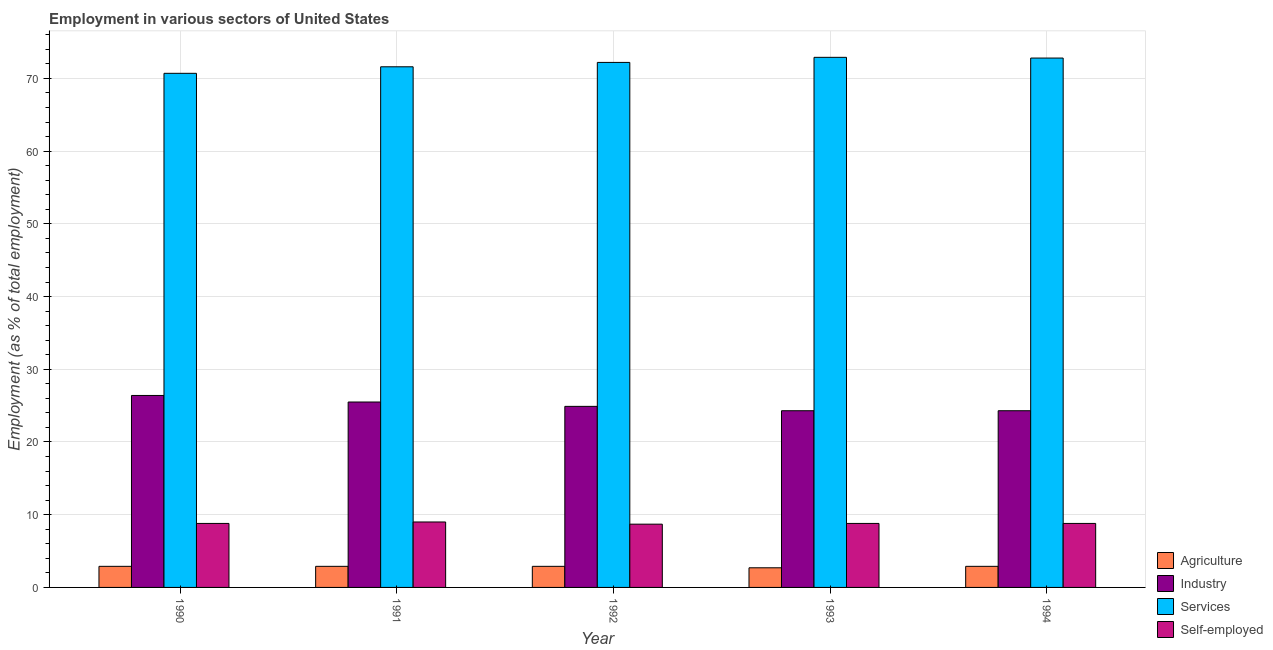How many different coloured bars are there?
Offer a terse response. 4. Are the number of bars per tick equal to the number of legend labels?
Offer a terse response. Yes. Are the number of bars on each tick of the X-axis equal?
Provide a short and direct response. Yes. How many bars are there on the 4th tick from the left?
Provide a succinct answer. 4. In how many cases, is the number of bars for a given year not equal to the number of legend labels?
Your answer should be very brief. 0. What is the percentage of workers in industry in 1990?
Your response must be concise. 26.4. Across all years, what is the maximum percentage of workers in industry?
Your answer should be compact. 26.4. Across all years, what is the minimum percentage of workers in agriculture?
Make the answer very short. 2.7. In which year was the percentage of workers in industry maximum?
Keep it short and to the point. 1990. What is the total percentage of workers in services in the graph?
Your answer should be compact. 360.2. What is the difference between the percentage of self employed workers in 1991 and that in 1994?
Keep it short and to the point. 0.2. What is the difference between the percentage of workers in services in 1991 and the percentage of workers in industry in 1994?
Provide a succinct answer. -1.2. What is the average percentage of workers in agriculture per year?
Your response must be concise. 2.86. In the year 1991, what is the difference between the percentage of workers in agriculture and percentage of workers in industry?
Provide a short and direct response. 0. In how many years, is the percentage of workers in services greater than 56 %?
Offer a terse response. 5. What is the ratio of the percentage of workers in services in 1991 to that in 1994?
Provide a succinct answer. 0.98. Is the percentage of workers in services in 1990 less than that in 1992?
Offer a very short reply. Yes. What is the difference between the highest and the second highest percentage of workers in agriculture?
Your answer should be compact. 0. What is the difference between the highest and the lowest percentage of workers in agriculture?
Keep it short and to the point. 0.2. Is it the case that in every year, the sum of the percentage of workers in services and percentage of self employed workers is greater than the sum of percentage of workers in agriculture and percentage of workers in industry?
Your answer should be very brief. Yes. What does the 2nd bar from the left in 1991 represents?
Provide a short and direct response. Industry. What does the 1st bar from the right in 1993 represents?
Your response must be concise. Self-employed. Are all the bars in the graph horizontal?
Provide a short and direct response. No. How many years are there in the graph?
Your response must be concise. 5. Does the graph contain grids?
Provide a succinct answer. Yes. How many legend labels are there?
Your answer should be very brief. 4. What is the title of the graph?
Give a very brief answer. Employment in various sectors of United States. Does "Quality of public administration" appear as one of the legend labels in the graph?
Your answer should be very brief. No. What is the label or title of the Y-axis?
Offer a very short reply. Employment (as % of total employment). What is the Employment (as % of total employment) in Agriculture in 1990?
Ensure brevity in your answer.  2.9. What is the Employment (as % of total employment) of Industry in 1990?
Offer a terse response. 26.4. What is the Employment (as % of total employment) in Services in 1990?
Your answer should be very brief. 70.7. What is the Employment (as % of total employment) of Self-employed in 1990?
Provide a short and direct response. 8.8. What is the Employment (as % of total employment) of Agriculture in 1991?
Make the answer very short. 2.9. What is the Employment (as % of total employment) of Industry in 1991?
Offer a very short reply. 25.5. What is the Employment (as % of total employment) of Services in 1991?
Provide a short and direct response. 71.6. What is the Employment (as % of total employment) of Agriculture in 1992?
Your answer should be compact. 2.9. What is the Employment (as % of total employment) of Industry in 1992?
Make the answer very short. 24.9. What is the Employment (as % of total employment) in Services in 1992?
Give a very brief answer. 72.2. What is the Employment (as % of total employment) in Self-employed in 1992?
Offer a very short reply. 8.7. What is the Employment (as % of total employment) of Agriculture in 1993?
Offer a terse response. 2.7. What is the Employment (as % of total employment) of Industry in 1993?
Offer a very short reply. 24.3. What is the Employment (as % of total employment) in Services in 1993?
Your answer should be very brief. 72.9. What is the Employment (as % of total employment) in Self-employed in 1993?
Keep it short and to the point. 8.8. What is the Employment (as % of total employment) in Agriculture in 1994?
Offer a very short reply. 2.9. What is the Employment (as % of total employment) of Industry in 1994?
Keep it short and to the point. 24.3. What is the Employment (as % of total employment) in Services in 1994?
Your answer should be very brief. 72.8. What is the Employment (as % of total employment) in Self-employed in 1994?
Your answer should be compact. 8.8. Across all years, what is the maximum Employment (as % of total employment) of Agriculture?
Keep it short and to the point. 2.9. Across all years, what is the maximum Employment (as % of total employment) of Industry?
Your answer should be compact. 26.4. Across all years, what is the maximum Employment (as % of total employment) of Services?
Offer a terse response. 72.9. Across all years, what is the maximum Employment (as % of total employment) of Self-employed?
Offer a terse response. 9. Across all years, what is the minimum Employment (as % of total employment) in Agriculture?
Provide a short and direct response. 2.7. Across all years, what is the minimum Employment (as % of total employment) of Industry?
Offer a very short reply. 24.3. Across all years, what is the minimum Employment (as % of total employment) of Services?
Make the answer very short. 70.7. Across all years, what is the minimum Employment (as % of total employment) of Self-employed?
Your answer should be very brief. 8.7. What is the total Employment (as % of total employment) of Agriculture in the graph?
Your answer should be very brief. 14.3. What is the total Employment (as % of total employment) in Industry in the graph?
Provide a short and direct response. 125.4. What is the total Employment (as % of total employment) in Services in the graph?
Provide a succinct answer. 360.2. What is the total Employment (as % of total employment) of Self-employed in the graph?
Provide a succinct answer. 44.1. What is the difference between the Employment (as % of total employment) of Agriculture in 1990 and that in 1991?
Your answer should be very brief. 0. What is the difference between the Employment (as % of total employment) of Industry in 1990 and that in 1991?
Ensure brevity in your answer.  0.9. What is the difference between the Employment (as % of total employment) in Agriculture in 1990 and that in 1992?
Offer a very short reply. 0. What is the difference between the Employment (as % of total employment) of Services in 1990 and that in 1992?
Your response must be concise. -1.5. What is the difference between the Employment (as % of total employment) in Self-employed in 1990 and that in 1992?
Provide a succinct answer. 0.1. What is the difference between the Employment (as % of total employment) of Agriculture in 1990 and that in 1993?
Your answer should be very brief. 0.2. What is the difference between the Employment (as % of total employment) of Self-employed in 1990 and that in 1993?
Give a very brief answer. 0. What is the difference between the Employment (as % of total employment) of Industry in 1990 and that in 1994?
Offer a terse response. 2.1. What is the difference between the Employment (as % of total employment) of Self-employed in 1990 and that in 1994?
Your answer should be very brief. 0. What is the difference between the Employment (as % of total employment) of Services in 1991 and that in 1992?
Keep it short and to the point. -0.6. What is the difference between the Employment (as % of total employment) of Self-employed in 1991 and that in 1992?
Provide a succinct answer. 0.3. What is the difference between the Employment (as % of total employment) of Services in 1991 and that in 1993?
Provide a succinct answer. -1.3. What is the difference between the Employment (as % of total employment) in Self-employed in 1991 and that in 1993?
Give a very brief answer. 0.2. What is the difference between the Employment (as % of total employment) of Services in 1991 and that in 1994?
Offer a very short reply. -1.2. What is the difference between the Employment (as % of total employment) of Industry in 1992 and that in 1993?
Offer a terse response. 0.6. What is the difference between the Employment (as % of total employment) in Services in 1992 and that in 1993?
Offer a terse response. -0.7. What is the difference between the Employment (as % of total employment) of Industry in 1992 and that in 1994?
Give a very brief answer. 0.6. What is the difference between the Employment (as % of total employment) in Agriculture in 1993 and that in 1994?
Offer a terse response. -0.2. What is the difference between the Employment (as % of total employment) in Services in 1993 and that in 1994?
Make the answer very short. 0.1. What is the difference between the Employment (as % of total employment) of Agriculture in 1990 and the Employment (as % of total employment) of Industry in 1991?
Offer a very short reply. -22.6. What is the difference between the Employment (as % of total employment) in Agriculture in 1990 and the Employment (as % of total employment) in Services in 1991?
Your answer should be compact. -68.7. What is the difference between the Employment (as % of total employment) of Agriculture in 1990 and the Employment (as % of total employment) of Self-employed in 1991?
Offer a terse response. -6.1. What is the difference between the Employment (as % of total employment) in Industry in 1990 and the Employment (as % of total employment) in Services in 1991?
Offer a terse response. -45.2. What is the difference between the Employment (as % of total employment) in Industry in 1990 and the Employment (as % of total employment) in Self-employed in 1991?
Make the answer very short. 17.4. What is the difference between the Employment (as % of total employment) of Services in 1990 and the Employment (as % of total employment) of Self-employed in 1991?
Keep it short and to the point. 61.7. What is the difference between the Employment (as % of total employment) in Agriculture in 1990 and the Employment (as % of total employment) in Industry in 1992?
Provide a short and direct response. -22. What is the difference between the Employment (as % of total employment) in Agriculture in 1990 and the Employment (as % of total employment) in Services in 1992?
Your response must be concise. -69.3. What is the difference between the Employment (as % of total employment) in Agriculture in 1990 and the Employment (as % of total employment) in Self-employed in 1992?
Make the answer very short. -5.8. What is the difference between the Employment (as % of total employment) of Industry in 1990 and the Employment (as % of total employment) of Services in 1992?
Your answer should be very brief. -45.8. What is the difference between the Employment (as % of total employment) in Industry in 1990 and the Employment (as % of total employment) in Self-employed in 1992?
Your answer should be very brief. 17.7. What is the difference between the Employment (as % of total employment) of Agriculture in 1990 and the Employment (as % of total employment) of Industry in 1993?
Make the answer very short. -21.4. What is the difference between the Employment (as % of total employment) in Agriculture in 1990 and the Employment (as % of total employment) in Services in 1993?
Give a very brief answer. -70. What is the difference between the Employment (as % of total employment) of Industry in 1990 and the Employment (as % of total employment) of Services in 1993?
Your answer should be compact. -46.5. What is the difference between the Employment (as % of total employment) of Industry in 1990 and the Employment (as % of total employment) of Self-employed in 1993?
Your answer should be compact. 17.6. What is the difference between the Employment (as % of total employment) of Services in 1990 and the Employment (as % of total employment) of Self-employed in 1993?
Provide a short and direct response. 61.9. What is the difference between the Employment (as % of total employment) of Agriculture in 1990 and the Employment (as % of total employment) of Industry in 1994?
Make the answer very short. -21.4. What is the difference between the Employment (as % of total employment) in Agriculture in 1990 and the Employment (as % of total employment) in Services in 1994?
Your answer should be compact. -69.9. What is the difference between the Employment (as % of total employment) in Industry in 1990 and the Employment (as % of total employment) in Services in 1994?
Offer a terse response. -46.4. What is the difference between the Employment (as % of total employment) in Industry in 1990 and the Employment (as % of total employment) in Self-employed in 1994?
Make the answer very short. 17.6. What is the difference between the Employment (as % of total employment) in Services in 1990 and the Employment (as % of total employment) in Self-employed in 1994?
Make the answer very short. 61.9. What is the difference between the Employment (as % of total employment) of Agriculture in 1991 and the Employment (as % of total employment) of Industry in 1992?
Keep it short and to the point. -22. What is the difference between the Employment (as % of total employment) of Agriculture in 1991 and the Employment (as % of total employment) of Services in 1992?
Provide a short and direct response. -69.3. What is the difference between the Employment (as % of total employment) in Industry in 1991 and the Employment (as % of total employment) in Services in 1992?
Ensure brevity in your answer.  -46.7. What is the difference between the Employment (as % of total employment) in Industry in 1991 and the Employment (as % of total employment) in Self-employed in 1992?
Offer a very short reply. 16.8. What is the difference between the Employment (as % of total employment) in Services in 1991 and the Employment (as % of total employment) in Self-employed in 1992?
Your response must be concise. 62.9. What is the difference between the Employment (as % of total employment) in Agriculture in 1991 and the Employment (as % of total employment) in Industry in 1993?
Ensure brevity in your answer.  -21.4. What is the difference between the Employment (as % of total employment) of Agriculture in 1991 and the Employment (as % of total employment) of Services in 1993?
Give a very brief answer. -70. What is the difference between the Employment (as % of total employment) of Industry in 1991 and the Employment (as % of total employment) of Services in 1993?
Keep it short and to the point. -47.4. What is the difference between the Employment (as % of total employment) in Services in 1991 and the Employment (as % of total employment) in Self-employed in 1993?
Make the answer very short. 62.8. What is the difference between the Employment (as % of total employment) of Agriculture in 1991 and the Employment (as % of total employment) of Industry in 1994?
Offer a terse response. -21.4. What is the difference between the Employment (as % of total employment) of Agriculture in 1991 and the Employment (as % of total employment) of Services in 1994?
Your response must be concise. -69.9. What is the difference between the Employment (as % of total employment) of Industry in 1991 and the Employment (as % of total employment) of Services in 1994?
Provide a short and direct response. -47.3. What is the difference between the Employment (as % of total employment) in Services in 1991 and the Employment (as % of total employment) in Self-employed in 1994?
Make the answer very short. 62.8. What is the difference between the Employment (as % of total employment) of Agriculture in 1992 and the Employment (as % of total employment) of Industry in 1993?
Ensure brevity in your answer.  -21.4. What is the difference between the Employment (as % of total employment) in Agriculture in 1992 and the Employment (as % of total employment) in Services in 1993?
Provide a succinct answer. -70. What is the difference between the Employment (as % of total employment) in Industry in 1992 and the Employment (as % of total employment) in Services in 1993?
Your response must be concise. -48. What is the difference between the Employment (as % of total employment) of Industry in 1992 and the Employment (as % of total employment) of Self-employed in 1993?
Offer a very short reply. 16.1. What is the difference between the Employment (as % of total employment) in Services in 1992 and the Employment (as % of total employment) in Self-employed in 1993?
Make the answer very short. 63.4. What is the difference between the Employment (as % of total employment) of Agriculture in 1992 and the Employment (as % of total employment) of Industry in 1994?
Keep it short and to the point. -21.4. What is the difference between the Employment (as % of total employment) of Agriculture in 1992 and the Employment (as % of total employment) of Services in 1994?
Offer a very short reply. -69.9. What is the difference between the Employment (as % of total employment) in Agriculture in 1992 and the Employment (as % of total employment) in Self-employed in 1994?
Give a very brief answer. -5.9. What is the difference between the Employment (as % of total employment) of Industry in 1992 and the Employment (as % of total employment) of Services in 1994?
Provide a succinct answer. -47.9. What is the difference between the Employment (as % of total employment) in Services in 1992 and the Employment (as % of total employment) in Self-employed in 1994?
Provide a short and direct response. 63.4. What is the difference between the Employment (as % of total employment) in Agriculture in 1993 and the Employment (as % of total employment) in Industry in 1994?
Provide a succinct answer. -21.6. What is the difference between the Employment (as % of total employment) in Agriculture in 1993 and the Employment (as % of total employment) in Services in 1994?
Offer a very short reply. -70.1. What is the difference between the Employment (as % of total employment) of Agriculture in 1993 and the Employment (as % of total employment) of Self-employed in 1994?
Your response must be concise. -6.1. What is the difference between the Employment (as % of total employment) in Industry in 1993 and the Employment (as % of total employment) in Services in 1994?
Give a very brief answer. -48.5. What is the difference between the Employment (as % of total employment) in Services in 1993 and the Employment (as % of total employment) in Self-employed in 1994?
Provide a short and direct response. 64.1. What is the average Employment (as % of total employment) in Agriculture per year?
Your response must be concise. 2.86. What is the average Employment (as % of total employment) in Industry per year?
Your answer should be very brief. 25.08. What is the average Employment (as % of total employment) of Services per year?
Provide a short and direct response. 72.04. What is the average Employment (as % of total employment) in Self-employed per year?
Your answer should be compact. 8.82. In the year 1990, what is the difference between the Employment (as % of total employment) in Agriculture and Employment (as % of total employment) in Industry?
Ensure brevity in your answer.  -23.5. In the year 1990, what is the difference between the Employment (as % of total employment) of Agriculture and Employment (as % of total employment) of Services?
Your answer should be compact. -67.8. In the year 1990, what is the difference between the Employment (as % of total employment) of Agriculture and Employment (as % of total employment) of Self-employed?
Offer a terse response. -5.9. In the year 1990, what is the difference between the Employment (as % of total employment) in Industry and Employment (as % of total employment) in Services?
Offer a very short reply. -44.3. In the year 1990, what is the difference between the Employment (as % of total employment) of Industry and Employment (as % of total employment) of Self-employed?
Make the answer very short. 17.6. In the year 1990, what is the difference between the Employment (as % of total employment) of Services and Employment (as % of total employment) of Self-employed?
Offer a very short reply. 61.9. In the year 1991, what is the difference between the Employment (as % of total employment) of Agriculture and Employment (as % of total employment) of Industry?
Give a very brief answer. -22.6. In the year 1991, what is the difference between the Employment (as % of total employment) in Agriculture and Employment (as % of total employment) in Services?
Provide a succinct answer. -68.7. In the year 1991, what is the difference between the Employment (as % of total employment) of Industry and Employment (as % of total employment) of Services?
Ensure brevity in your answer.  -46.1. In the year 1991, what is the difference between the Employment (as % of total employment) of Services and Employment (as % of total employment) of Self-employed?
Give a very brief answer. 62.6. In the year 1992, what is the difference between the Employment (as % of total employment) in Agriculture and Employment (as % of total employment) in Services?
Your answer should be very brief. -69.3. In the year 1992, what is the difference between the Employment (as % of total employment) of Agriculture and Employment (as % of total employment) of Self-employed?
Your response must be concise. -5.8. In the year 1992, what is the difference between the Employment (as % of total employment) of Industry and Employment (as % of total employment) of Services?
Provide a short and direct response. -47.3. In the year 1992, what is the difference between the Employment (as % of total employment) of Services and Employment (as % of total employment) of Self-employed?
Give a very brief answer. 63.5. In the year 1993, what is the difference between the Employment (as % of total employment) of Agriculture and Employment (as % of total employment) of Industry?
Offer a terse response. -21.6. In the year 1993, what is the difference between the Employment (as % of total employment) of Agriculture and Employment (as % of total employment) of Services?
Make the answer very short. -70.2. In the year 1993, what is the difference between the Employment (as % of total employment) of Agriculture and Employment (as % of total employment) of Self-employed?
Give a very brief answer. -6.1. In the year 1993, what is the difference between the Employment (as % of total employment) of Industry and Employment (as % of total employment) of Services?
Offer a terse response. -48.6. In the year 1993, what is the difference between the Employment (as % of total employment) in Industry and Employment (as % of total employment) in Self-employed?
Ensure brevity in your answer.  15.5. In the year 1993, what is the difference between the Employment (as % of total employment) in Services and Employment (as % of total employment) in Self-employed?
Keep it short and to the point. 64.1. In the year 1994, what is the difference between the Employment (as % of total employment) in Agriculture and Employment (as % of total employment) in Industry?
Make the answer very short. -21.4. In the year 1994, what is the difference between the Employment (as % of total employment) in Agriculture and Employment (as % of total employment) in Services?
Provide a short and direct response. -69.9. In the year 1994, what is the difference between the Employment (as % of total employment) in Industry and Employment (as % of total employment) in Services?
Offer a very short reply. -48.5. In the year 1994, what is the difference between the Employment (as % of total employment) of Industry and Employment (as % of total employment) of Self-employed?
Give a very brief answer. 15.5. What is the ratio of the Employment (as % of total employment) of Industry in 1990 to that in 1991?
Provide a short and direct response. 1.04. What is the ratio of the Employment (as % of total employment) in Services in 1990 to that in 1991?
Make the answer very short. 0.99. What is the ratio of the Employment (as % of total employment) in Self-employed in 1990 to that in 1991?
Give a very brief answer. 0.98. What is the ratio of the Employment (as % of total employment) of Agriculture in 1990 to that in 1992?
Provide a succinct answer. 1. What is the ratio of the Employment (as % of total employment) in Industry in 1990 to that in 1992?
Provide a succinct answer. 1.06. What is the ratio of the Employment (as % of total employment) in Services in 1990 to that in 1992?
Give a very brief answer. 0.98. What is the ratio of the Employment (as % of total employment) in Self-employed in 1990 to that in 1992?
Keep it short and to the point. 1.01. What is the ratio of the Employment (as % of total employment) of Agriculture in 1990 to that in 1993?
Provide a succinct answer. 1.07. What is the ratio of the Employment (as % of total employment) of Industry in 1990 to that in 1993?
Provide a short and direct response. 1.09. What is the ratio of the Employment (as % of total employment) in Services in 1990 to that in 1993?
Keep it short and to the point. 0.97. What is the ratio of the Employment (as % of total employment) of Self-employed in 1990 to that in 1993?
Offer a very short reply. 1. What is the ratio of the Employment (as % of total employment) of Industry in 1990 to that in 1994?
Offer a terse response. 1.09. What is the ratio of the Employment (as % of total employment) of Services in 1990 to that in 1994?
Provide a short and direct response. 0.97. What is the ratio of the Employment (as % of total employment) in Agriculture in 1991 to that in 1992?
Make the answer very short. 1. What is the ratio of the Employment (as % of total employment) of Industry in 1991 to that in 1992?
Your response must be concise. 1.02. What is the ratio of the Employment (as % of total employment) of Services in 1991 to that in 1992?
Offer a terse response. 0.99. What is the ratio of the Employment (as % of total employment) in Self-employed in 1991 to that in 1992?
Provide a succinct answer. 1.03. What is the ratio of the Employment (as % of total employment) in Agriculture in 1991 to that in 1993?
Give a very brief answer. 1.07. What is the ratio of the Employment (as % of total employment) in Industry in 1991 to that in 1993?
Give a very brief answer. 1.05. What is the ratio of the Employment (as % of total employment) in Services in 1991 to that in 1993?
Your response must be concise. 0.98. What is the ratio of the Employment (as % of total employment) in Self-employed in 1991 to that in 1993?
Make the answer very short. 1.02. What is the ratio of the Employment (as % of total employment) of Agriculture in 1991 to that in 1994?
Give a very brief answer. 1. What is the ratio of the Employment (as % of total employment) in Industry in 1991 to that in 1994?
Provide a succinct answer. 1.05. What is the ratio of the Employment (as % of total employment) in Services in 1991 to that in 1994?
Make the answer very short. 0.98. What is the ratio of the Employment (as % of total employment) of Self-employed in 1991 to that in 1994?
Keep it short and to the point. 1.02. What is the ratio of the Employment (as % of total employment) of Agriculture in 1992 to that in 1993?
Keep it short and to the point. 1.07. What is the ratio of the Employment (as % of total employment) of Industry in 1992 to that in 1993?
Provide a succinct answer. 1.02. What is the ratio of the Employment (as % of total employment) of Services in 1992 to that in 1993?
Keep it short and to the point. 0.99. What is the ratio of the Employment (as % of total employment) in Industry in 1992 to that in 1994?
Offer a terse response. 1.02. What is the ratio of the Employment (as % of total employment) of Services in 1992 to that in 1994?
Provide a succinct answer. 0.99. What is the ratio of the Employment (as % of total employment) in Self-employed in 1992 to that in 1994?
Your answer should be very brief. 0.99. What is the ratio of the Employment (as % of total employment) of Services in 1993 to that in 1994?
Ensure brevity in your answer.  1. What is the difference between the highest and the second highest Employment (as % of total employment) of Agriculture?
Give a very brief answer. 0. What is the difference between the highest and the second highest Employment (as % of total employment) in Industry?
Offer a terse response. 0.9. What is the difference between the highest and the second highest Employment (as % of total employment) in Self-employed?
Offer a terse response. 0.2. What is the difference between the highest and the lowest Employment (as % of total employment) of Agriculture?
Give a very brief answer. 0.2. 